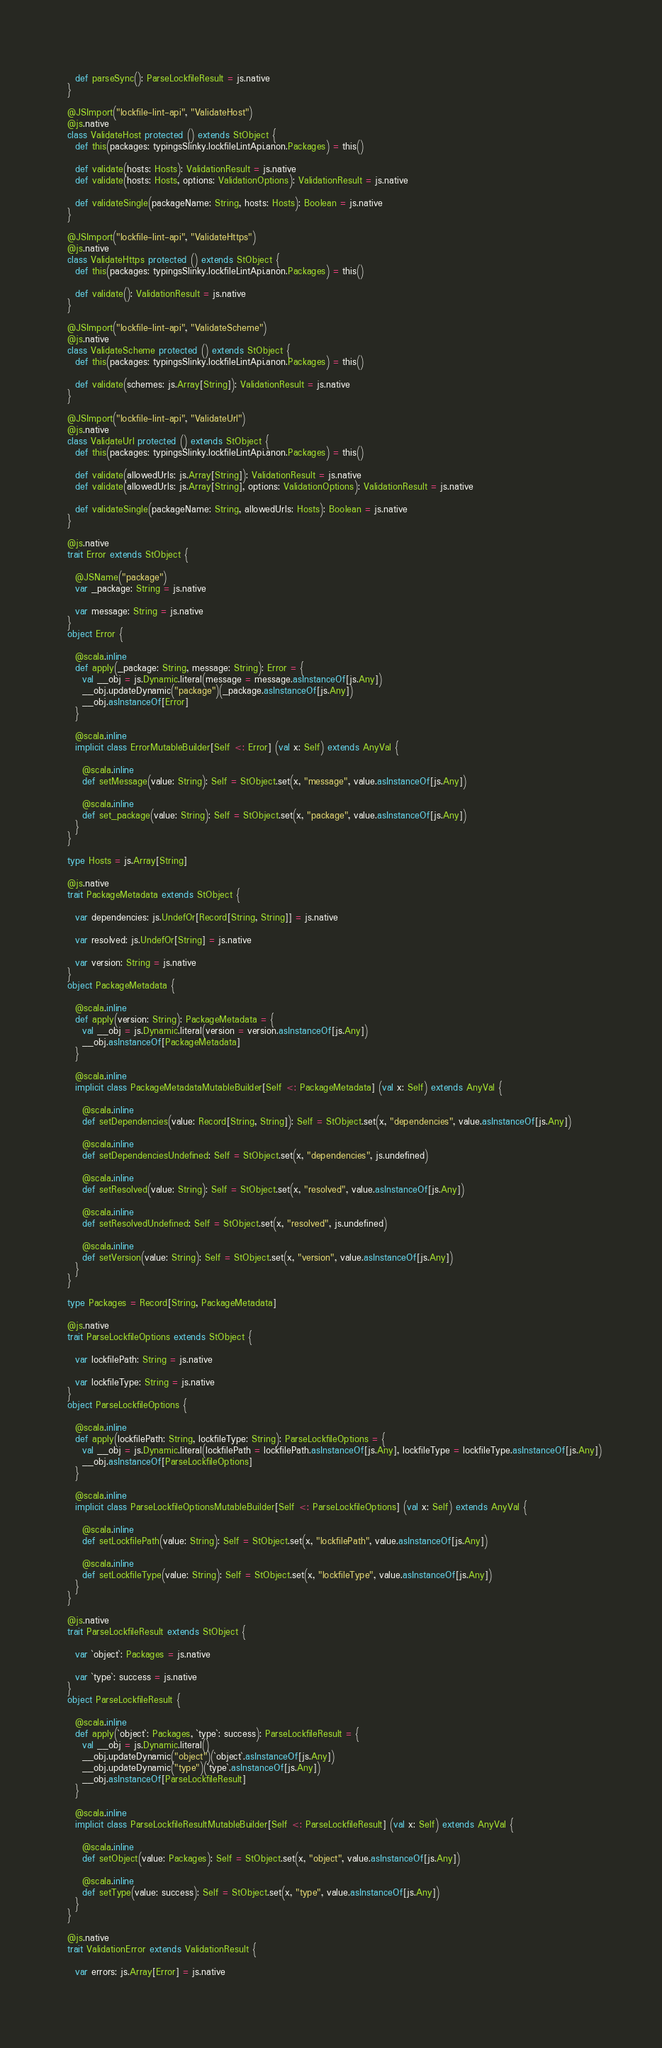Convert code to text. <code><loc_0><loc_0><loc_500><loc_500><_Scala_>    
    def parseSync(): ParseLockfileResult = js.native
  }
  
  @JSImport("lockfile-lint-api", "ValidateHost")
  @js.native
  class ValidateHost protected () extends StObject {
    def this(packages: typingsSlinky.lockfileLintApi.anon.Packages) = this()
    
    def validate(hosts: Hosts): ValidationResult = js.native
    def validate(hosts: Hosts, options: ValidationOptions): ValidationResult = js.native
    
    def validateSingle(packageName: String, hosts: Hosts): Boolean = js.native
  }
  
  @JSImport("lockfile-lint-api", "ValidateHttps")
  @js.native
  class ValidateHttps protected () extends StObject {
    def this(packages: typingsSlinky.lockfileLintApi.anon.Packages) = this()
    
    def validate(): ValidationResult = js.native
  }
  
  @JSImport("lockfile-lint-api", "ValidateScheme")
  @js.native
  class ValidateScheme protected () extends StObject {
    def this(packages: typingsSlinky.lockfileLintApi.anon.Packages) = this()
    
    def validate(schemes: js.Array[String]): ValidationResult = js.native
  }
  
  @JSImport("lockfile-lint-api", "ValidateUrl")
  @js.native
  class ValidateUrl protected () extends StObject {
    def this(packages: typingsSlinky.lockfileLintApi.anon.Packages) = this()
    
    def validate(allowedUrls: js.Array[String]): ValidationResult = js.native
    def validate(allowedUrls: js.Array[String], options: ValidationOptions): ValidationResult = js.native
    
    def validateSingle(packageName: String, allowedUrls: Hosts): Boolean = js.native
  }
  
  @js.native
  trait Error extends StObject {
    
    @JSName("package")
    var _package: String = js.native
    
    var message: String = js.native
  }
  object Error {
    
    @scala.inline
    def apply(_package: String, message: String): Error = {
      val __obj = js.Dynamic.literal(message = message.asInstanceOf[js.Any])
      __obj.updateDynamic("package")(_package.asInstanceOf[js.Any])
      __obj.asInstanceOf[Error]
    }
    
    @scala.inline
    implicit class ErrorMutableBuilder[Self <: Error] (val x: Self) extends AnyVal {
      
      @scala.inline
      def setMessage(value: String): Self = StObject.set(x, "message", value.asInstanceOf[js.Any])
      
      @scala.inline
      def set_package(value: String): Self = StObject.set(x, "package", value.asInstanceOf[js.Any])
    }
  }
  
  type Hosts = js.Array[String]
  
  @js.native
  trait PackageMetadata extends StObject {
    
    var dependencies: js.UndefOr[Record[String, String]] = js.native
    
    var resolved: js.UndefOr[String] = js.native
    
    var version: String = js.native
  }
  object PackageMetadata {
    
    @scala.inline
    def apply(version: String): PackageMetadata = {
      val __obj = js.Dynamic.literal(version = version.asInstanceOf[js.Any])
      __obj.asInstanceOf[PackageMetadata]
    }
    
    @scala.inline
    implicit class PackageMetadataMutableBuilder[Self <: PackageMetadata] (val x: Self) extends AnyVal {
      
      @scala.inline
      def setDependencies(value: Record[String, String]): Self = StObject.set(x, "dependencies", value.asInstanceOf[js.Any])
      
      @scala.inline
      def setDependenciesUndefined: Self = StObject.set(x, "dependencies", js.undefined)
      
      @scala.inline
      def setResolved(value: String): Self = StObject.set(x, "resolved", value.asInstanceOf[js.Any])
      
      @scala.inline
      def setResolvedUndefined: Self = StObject.set(x, "resolved", js.undefined)
      
      @scala.inline
      def setVersion(value: String): Self = StObject.set(x, "version", value.asInstanceOf[js.Any])
    }
  }
  
  type Packages = Record[String, PackageMetadata]
  
  @js.native
  trait ParseLockfileOptions extends StObject {
    
    var lockfilePath: String = js.native
    
    var lockfileType: String = js.native
  }
  object ParseLockfileOptions {
    
    @scala.inline
    def apply(lockfilePath: String, lockfileType: String): ParseLockfileOptions = {
      val __obj = js.Dynamic.literal(lockfilePath = lockfilePath.asInstanceOf[js.Any], lockfileType = lockfileType.asInstanceOf[js.Any])
      __obj.asInstanceOf[ParseLockfileOptions]
    }
    
    @scala.inline
    implicit class ParseLockfileOptionsMutableBuilder[Self <: ParseLockfileOptions] (val x: Self) extends AnyVal {
      
      @scala.inline
      def setLockfilePath(value: String): Self = StObject.set(x, "lockfilePath", value.asInstanceOf[js.Any])
      
      @scala.inline
      def setLockfileType(value: String): Self = StObject.set(x, "lockfileType", value.asInstanceOf[js.Any])
    }
  }
  
  @js.native
  trait ParseLockfileResult extends StObject {
    
    var `object`: Packages = js.native
    
    var `type`: success = js.native
  }
  object ParseLockfileResult {
    
    @scala.inline
    def apply(`object`: Packages, `type`: success): ParseLockfileResult = {
      val __obj = js.Dynamic.literal()
      __obj.updateDynamic("object")(`object`.asInstanceOf[js.Any])
      __obj.updateDynamic("type")(`type`.asInstanceOf[js.Any])
      __obj.asInstanceOf[ParseLockfileResult]
    }
    
    @scala.inline
    implicit class ParseLockfileResultMutableBuilder[Self <: ParseLockfileResult] (val x: Self) extends AnyVal {
      
      @scala.inline
      def setObject(value: Packages): Self = StObject.set(x, "object", value.asInstanceOf[js.Any])
      
      @scala.inline
      def setType(value: success): Self = StObject.set(x, "type", value.asInstanceOf[js.Any])
    }
  }
  
  @js.native
  trait ValidationError extends ValidationResult {
    
    var errors: js.Array[Error] = js.native
    </code> 